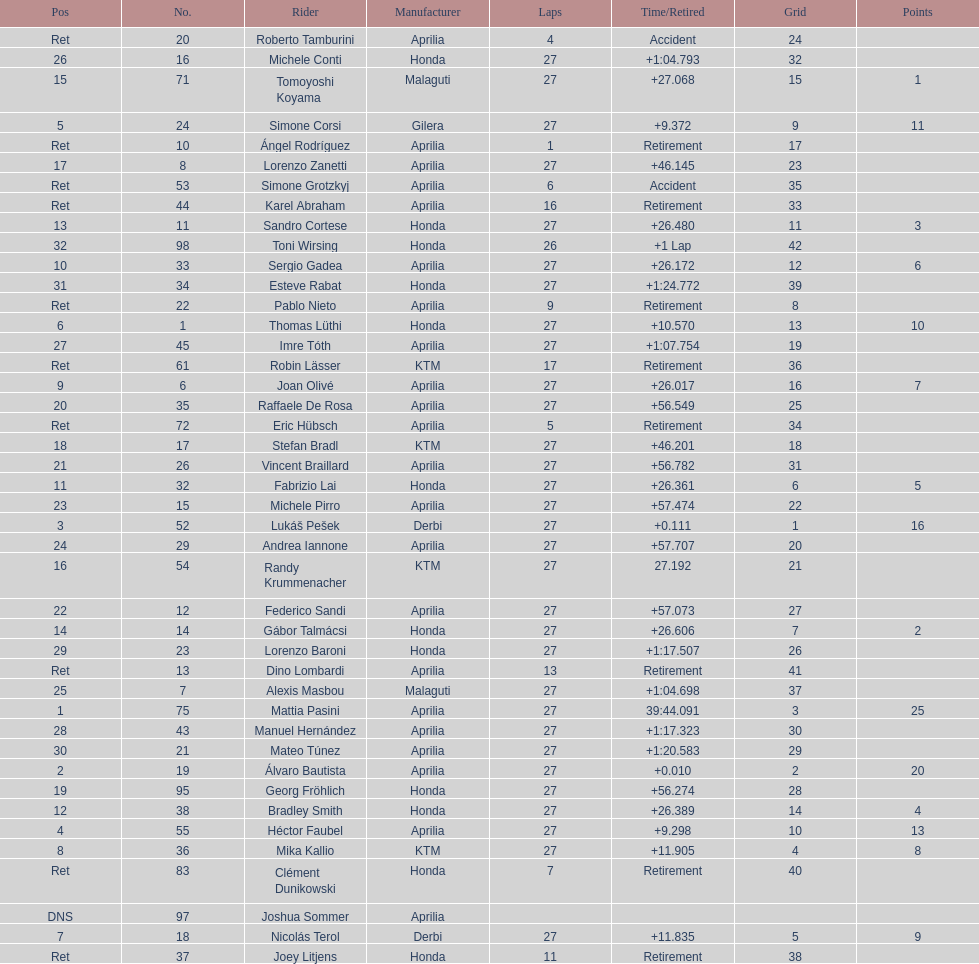How many german racers finished the race? 4. 